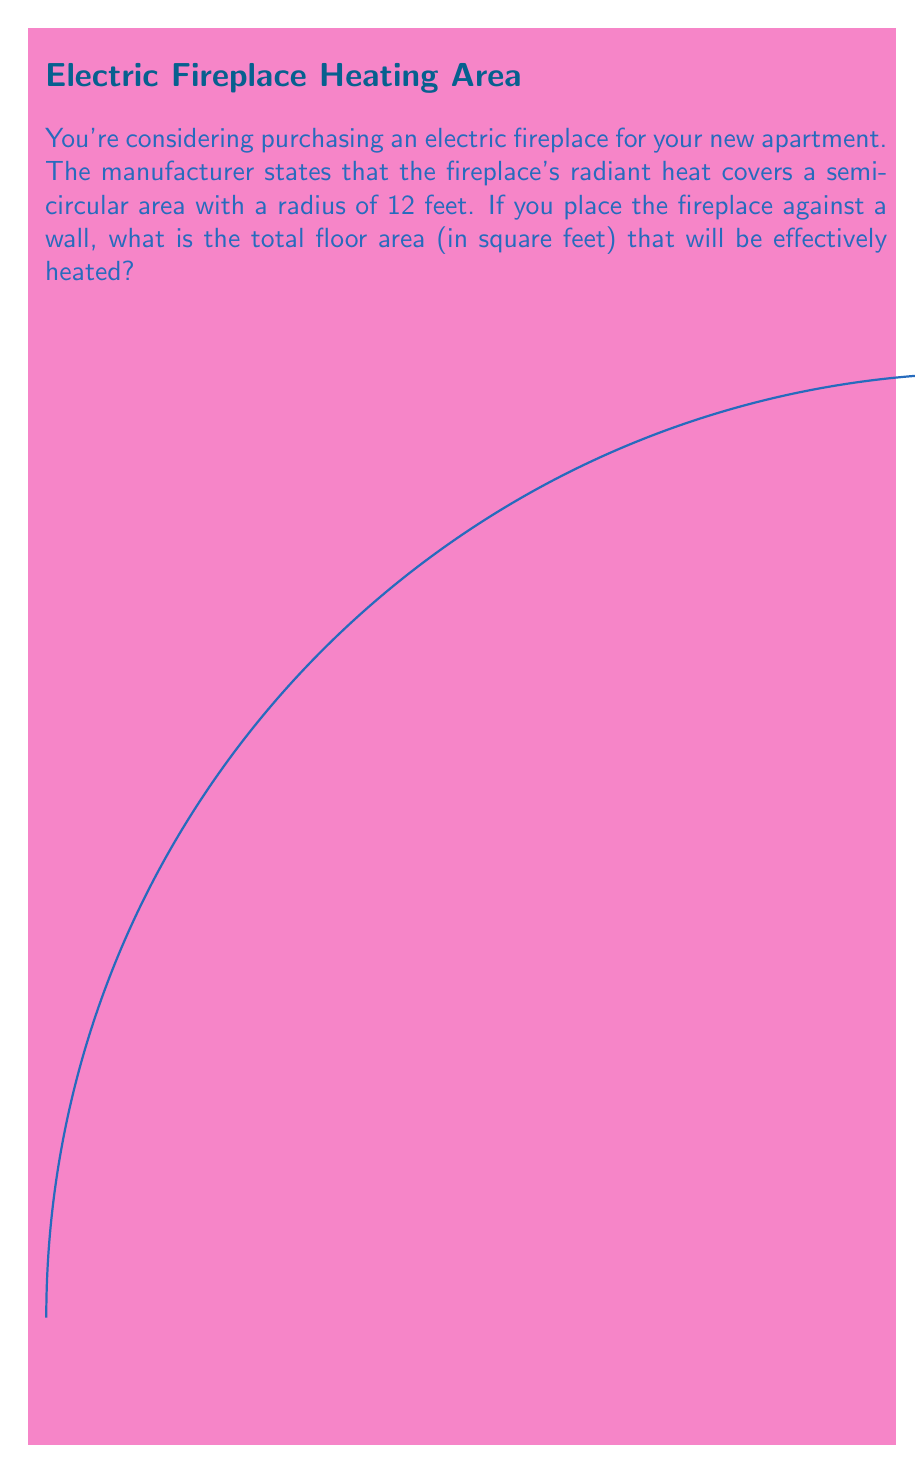Help me with this question. Let's approach this step-by-step:

1) The radiant heat covers a semicircular area. The area of a semicircle is given by the formula:

   $A = \frac{1}{2} \pi r^2$

   Where $A$ is the area and $r$ is the radius.

2) We're given that the radius is 12 feet. Let's substitute this into our formula:

   $A = \frac{1}{2} \pi (12)^2$

3) Let's calculate this:
   
   $A = \frac{1}{2} \pi (144)$
   $A = 72\pi$

4) Now, let's calculate this value:
   
   $A \approx 72 * 3.14159 \approx 226.19$ square feet

5) We need to round this to a whole number, as it's unlikely we'd measure floor space to decimal places.

Therefore, the heated floor area is approximately 226 square feet.
Answer: 226 sq ft 